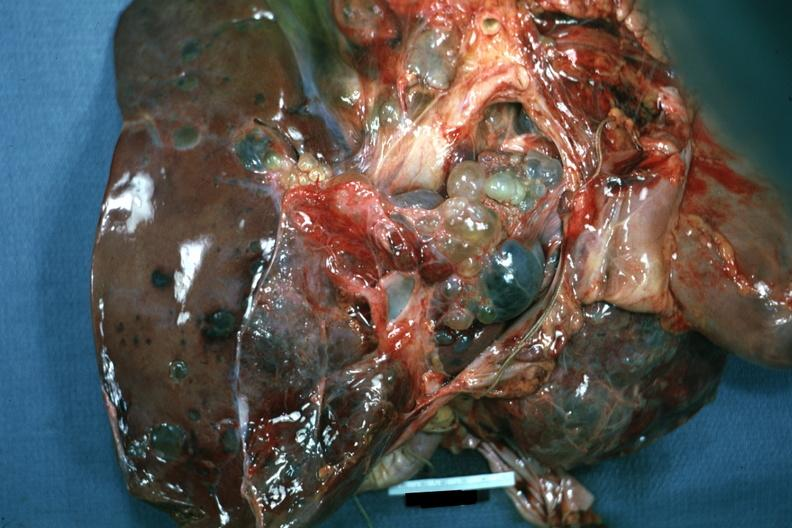s liver present?
Answer the question using a single word or phrase. Yes 